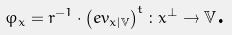Convert formula to latex. <formula><loc_0><loc_0><loc_500><loc_500>\varphi _ { x } = r ^ { - 1 } \cdot \left ( e v _ { x | \mathbb { V } } \right ) ^ { t } \colon x ^ { \bot } \rightarrow \mathbb { V } \text {.}</formula> 